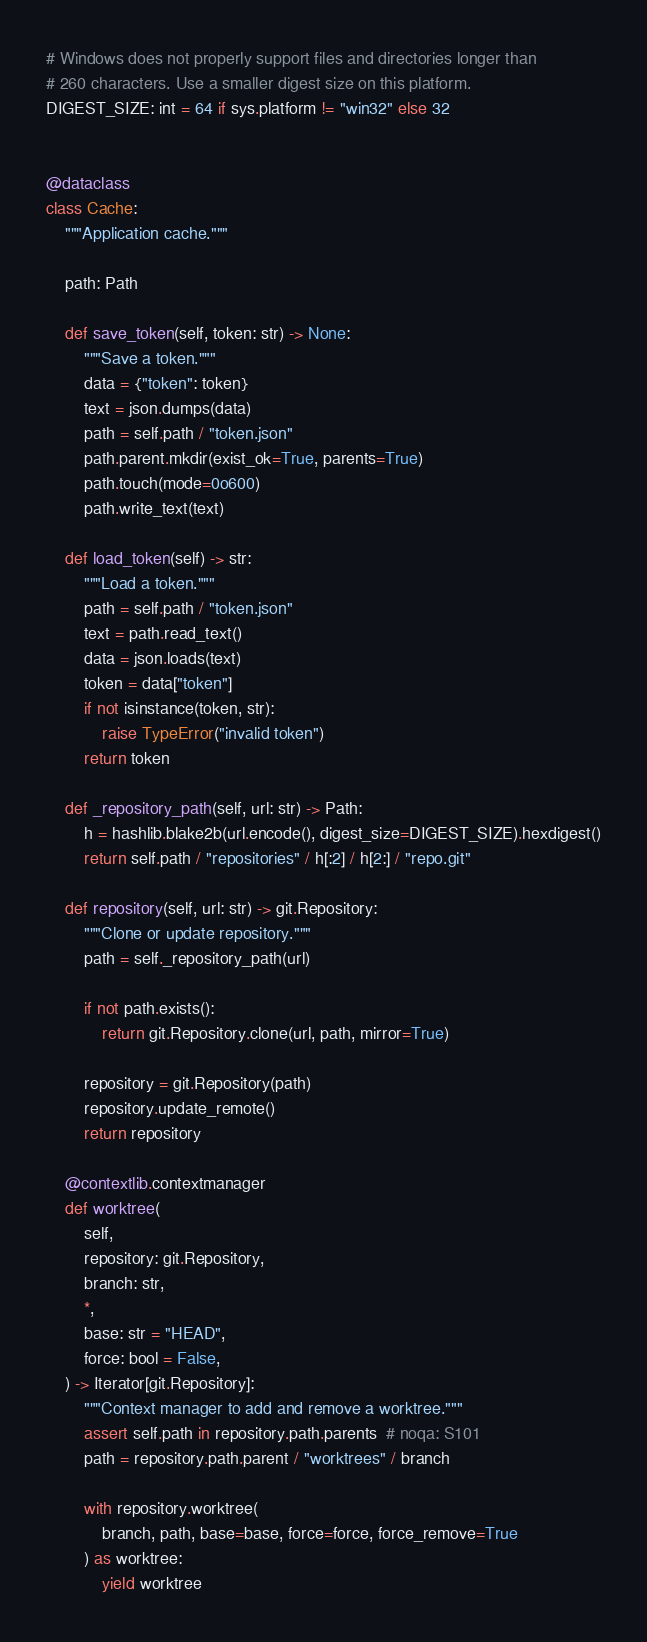<code> <loc_0><loc_0><loc_500><loc_500><_Python_># Windows does not properly support files and directories longer than
# 260 characters. Use a smaller digest size on this platform.
DIGEST_SIZE: int = 64 if sys.platform != "win32" else 32


@dataclass
class Cache:
    """Application cache."""

    path: Path

    def save_token(self, token: str) -> None:
        """Save a token."""
        data = {"token": token}
        text = json.dumps(data)
        path = self.path / "token.json"
        path.parent.mkdir(exist_ok=True, parents=True)
        path.touch(mode=0o600)
        path.write_text(text)

    def load_token(self) -> str:
        """Load a token."""
        path = self.path / "token.json"
        text = path.read_text()
        data = json.loads(text)
        token = data["token"]
        if not isinstance(token, str):
            raise TypeError("invalid token")
        return token

    def _repository_path(self, url: str) -> Path:
        h = hashlib.blake2b(url.encode(), digest_size=DIGEST_SIZE).hexdigest()
        return self.path / "repositories" / h[:2] / h[2:] / "repo.git"

    def repository(self, url: str) -> git.Repository:
        """Clone or update repository."""
        path = self._repository_path(url)

        if not path.exists():
            return git.Repository.clone(url, path, mirror=True)

        repository = git.Repository(path)
        repository.update_remote()
        return repository

    @contextlib.contextmanager
    def worktree(
        self,
        repository: git.Repository,
        branch: str,
        *,
        base: str = "HEAD",
        force: bool = False,
    ) -> Iterator[git.Repository]:
        """Context manager to add and remove a worktree."""
        assert self.path in repository.path.parents  # noqa: S101
        path = repository.path.parent / "worktrees" / branch

        with repository.worktree(
            branch, path, base=base, force=force, force_remove=True
        ) as worktree:
            yield worktree
</code> 